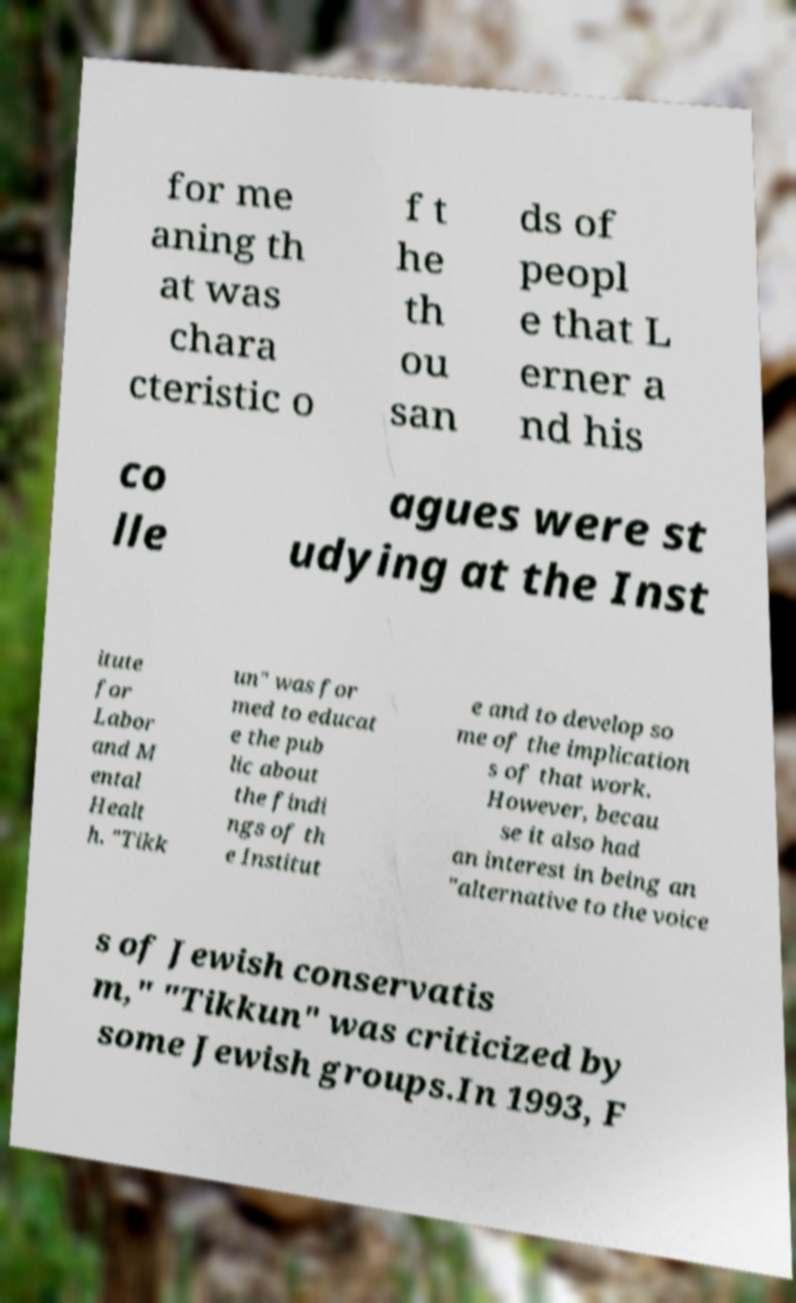Could you extract and type out the text from this image? for me aning th at was chara cteristic o f t he th ou san ds of peopl e that L erner a nd his co lle agues were st udying at the Inst itute for Labor and M ental Healt h. "Tikk un" was for med to educat e the pub lic about the findi ngs of th e Institut e and to develop so me of the implication s of that work. However, becau se it also had an interest in being an "alternative to the voice s of Jewish conservatis m," "Tikkun" was criticized by some Jewish groups.In 1993, F 